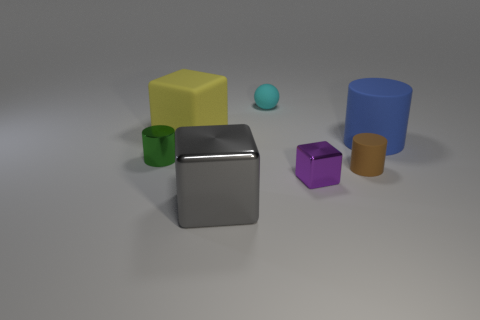Add 2 small blue matte blocks. How many objects exist? 9 Subtract all purple blocks. How many blocks are left? 2 Subtract all cylinders. How many objects are left? 4 Subtract 2 cylinders. How many cylinders are left? 1 Subtract all yellow cylinders. How many purple cubes are left? 1 Subtract all small red spheres. Subtract all big objects. How many objects are left? 4 Add 5 cylinders. How many cylinders are left? 8 Add 6 green rubber objects. How many green rubber objects exist? 6 Subtract 1 cyan spheres. How many objects are left? 6 Subtract all red blocks. Subtract all yellow cylinders. How many blocks are left? 3 